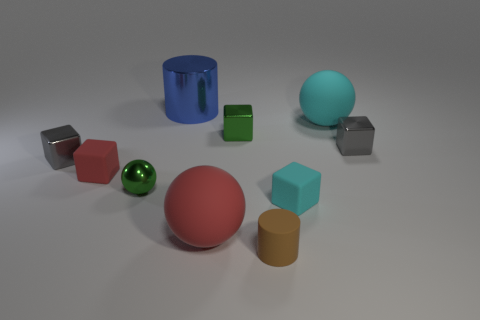Subtract all small green metal cubes. How many cubes are left? 4 Subtract all cyan cubes. How many cubes are left? 4 Subtract all blue cubes. Subtract all purple cylinders. How many cubes are left? 5 Subtract all cylinders. How many objects are left? 8 Add 2 tiny brown matte cylinders. How many tiny brown matte cylinders exist? 3 Subtract 0 blue cubes. How many objects are left? 10 Subtract all brown rubber cylinders. Subtract all big rubber blocks. How many objects are left? 9 Add 8 big blue objects. How many big blue objects are left? 9 